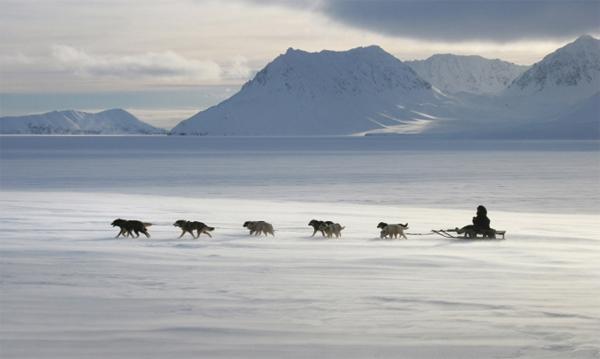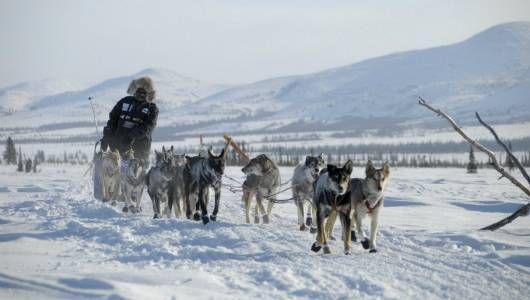The first image is the image on the left, the second image is the image on the right. Considering the images on both sides, is "The sled dog team on the left heads leftward, and the dog team on the right heads rightward, and each team appears to be moving." valid? Answer yes or no. Yes. The first image is the image on the left, the second image is the image on the right. Assess this claim about the two images: "There are less than three dogs on the snow in one of the images.". Correct or not? Answer yes or no. No. 